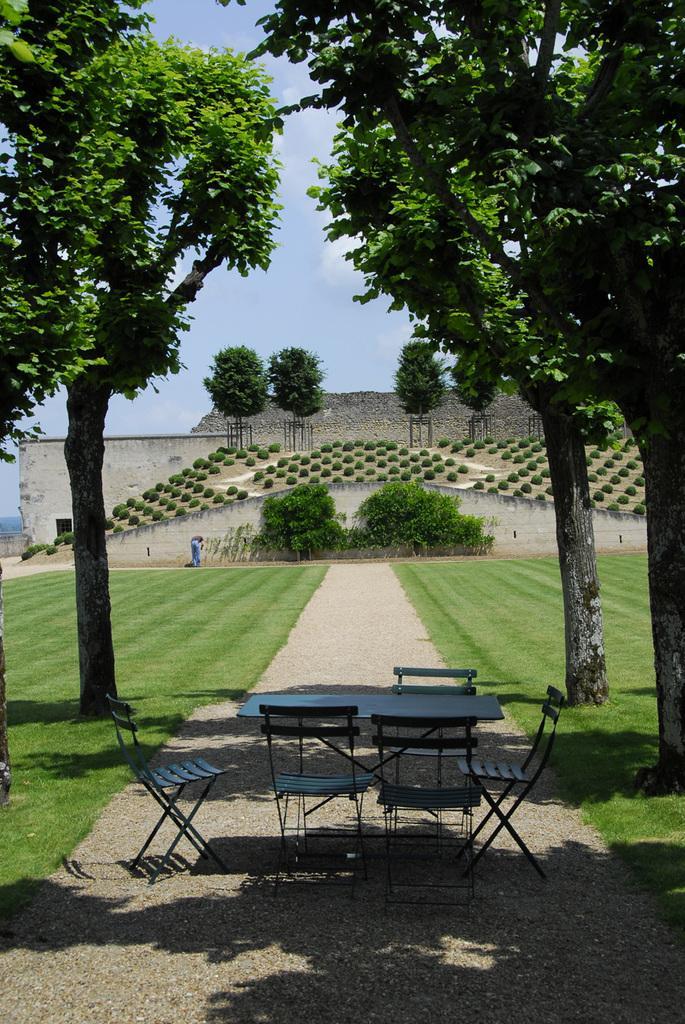Could you give a brief overview of what you see in this image? In this image I can see the table and the chairs. To the side of these chairs I can see many trees. In the background there is a person to the side of the wall. I can also see many trees, clouds and the sky in the back. 